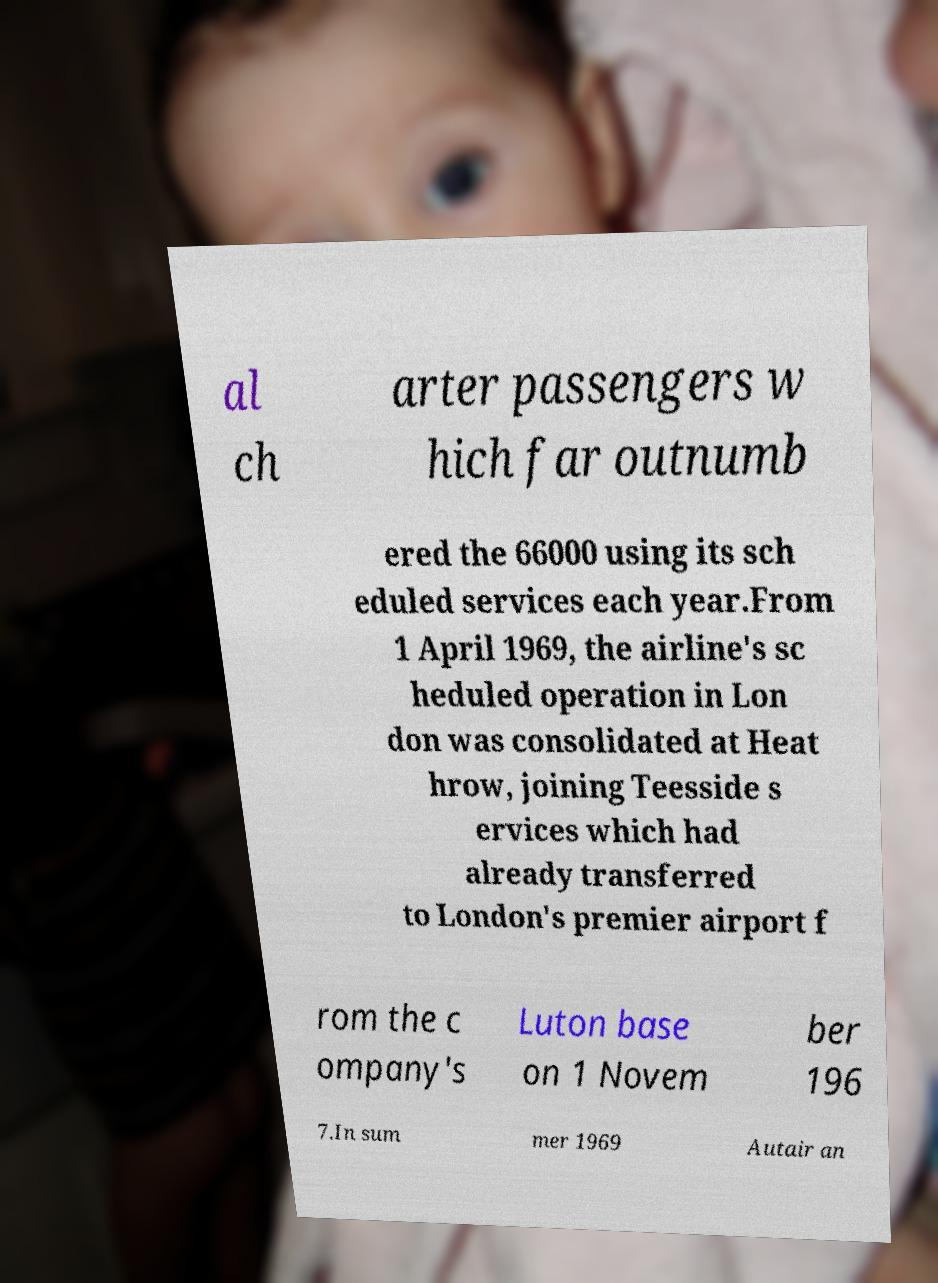Could you extract and type out the text from this image? al ch arter passengers w hich far outnumb ered the 66000 using its sch eduled services each year.From 1 April 1969, the airline's sc heduled operation in Lon don was consolidated at Heat hrow, joining Teesside s ervices which had already transferred to London's premier airport f rom the c ompany's Luton base on 1 Novem ber 196 7.In sum mer 1969 Autair an 